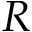Convert formula to latex. <formula><loc_0><loc_0><loc_500><loc_500>R</formula> 